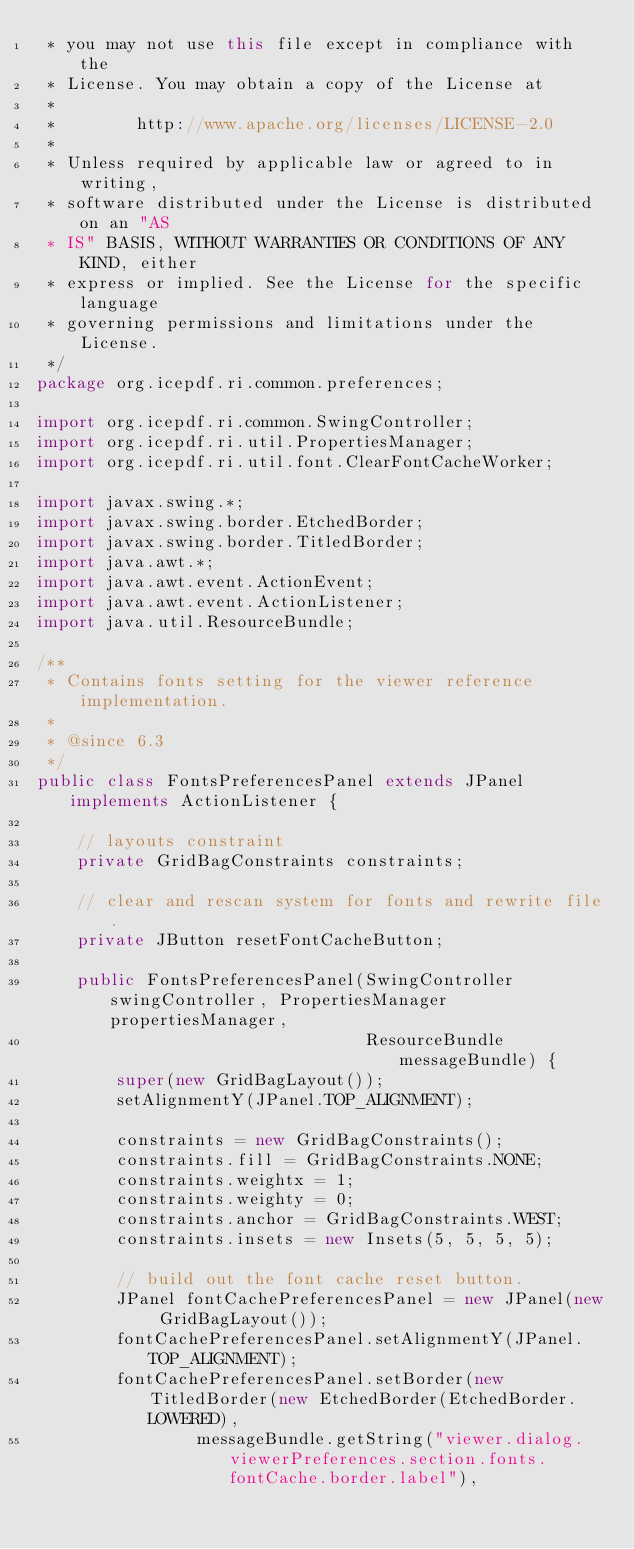<code> <loc_0><loc_0><loc_500><loc_500><_Java_> * you may not use this file except in compliance with the
 * License. You may obtain a copy of the License at
 *
 *        http://www.apache.org/licenses/LICENSE-2.0
 *
 * Unless required by applicable law or agreed to in writing,
 * software distributed under the License is distributed on an "AS
 * IS" BASIS, WITHOUT WARRANTIES OR CONDITIONS OF ANY KIND, either
 * express or implied. See the License for the specific language
 * governing permissions and limitations under the License.
 */
package org.icepdf.ri.common.preferences;

import org.icepdf.ri.common.SwingController;
import org.icepdf.ri.util.PropertiesManager;
import org.icepdf.ri.util.font.ClearFontCacheWorker;

import javax.swing.*;
import javax.swing.border.EtchedBorder;
import javax.swing.border.TitledBorder;
import java.awt.*;
import java.awt.event.ActionEvent;
import java.awt.event.ActionListener;
import java.util.ResourceBundle;

/**
 * Contains fonts setting for the viewer reference implementation.
 *
 * @since 6.3
 */
public class FontsPreferencesPanel extends JPanel implements ActionListener {

    // layouts constraint
    private GridBagConstraints constraints;

    // clear and rescan system for fonts and rewrite file.
    private JButton resetFontCacheButton;

    public FontsPreferencesPanel(SwingController swingController, PropertiesManager propertiesManager,
                                 ResourceBundle messageBundle) {
        super(new GridBagLayout());
        setAlignmentY(JPanel.TOP_ALIGNMENT);

        constraints = new GridBagConstraints();
        constraints.fill = GridBagConstraints.NONE;
        constraints.weightx = 1;
        constraints.weighty = 0;
        constraints.anchor = GridBagConstraints.WEST;
        constraints.insets = new Insets(5, 5, 5, 5);

        // build out the font cache reset button.
        JPanel fontCachePreferencesPanel = new JPanel(new GridBagLayout());
        fontCachePreferencesPanel.setAlignmentY(JPanel.TOP_ALIGNMENT);
        fontCachePreferencesPanel.setBorder(new TitledBorder(new EtchedBorder(EtchedBorder.LOWERED),
                messageBundle.getString("viewer.dialog.viewerPreferences.section.fonts.fontCache.border.label"),</code> 